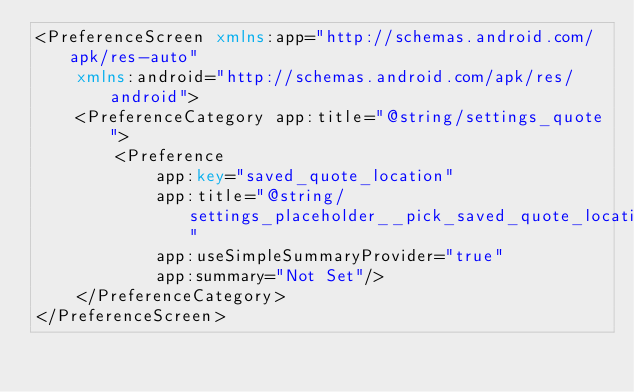<code> <loc_0><loc_0><loc_500><loc_500><_XML_><PreferenceScreen xmlns:app="http://schemas.android.com/apk/res-auto"
    xmlns:android="http://schemas.android.com/apk/res/android">
    <PreferenceCategory app:title="@string/settings_quote">
        <Preference
            app:key="saved_quote_location"
            app:title="@string/settings_placeholder__pick_saved_quote_location"
            app:useSimpleSummaryProvider="true"
            app:summary="Not Set"/>
    </PreferenceCategory>
</PreferenceScreen></code> 